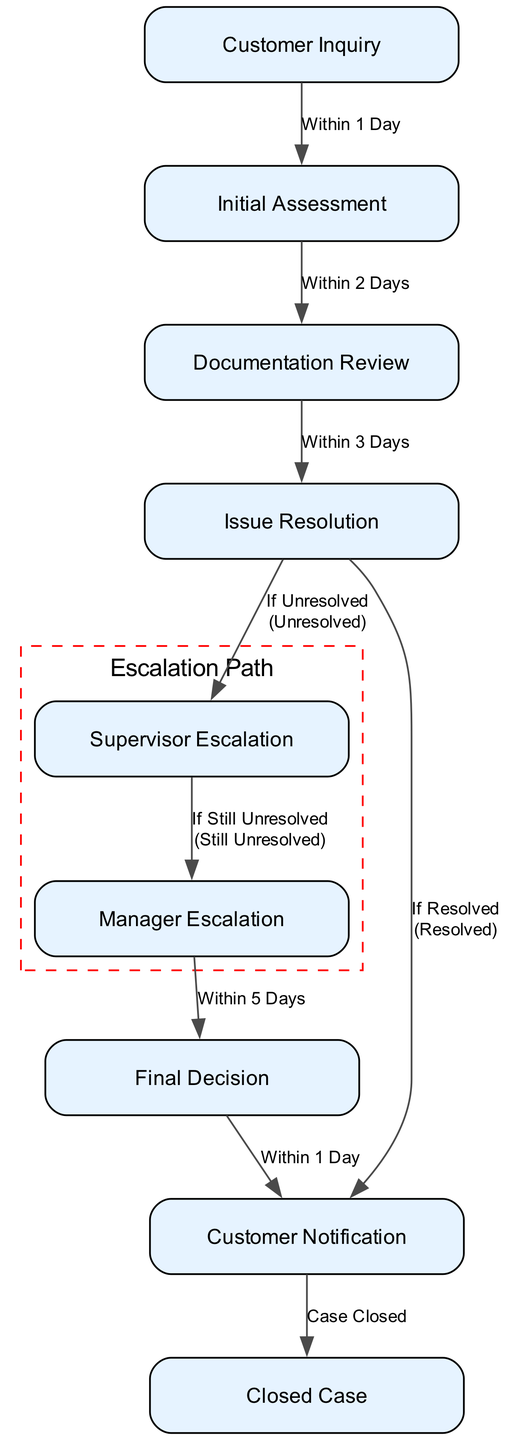What is the first node in the workflow diagram? The first node in the workflow diagram is "Customer Inquiry." This is determined by looking at the nodes listed in the diagram and identifying the one that initiates the process.
Answer: Customer Inquiry How many total nodes are present in the diagram? The diagram contains a total of 9 nodes, which can be counted from the list of nodes provided in the data.
Answer: 9 What is the condition for escalation to the supervisor? The condition for escalation to the supervisor is "If Unresolved." This is noted on the edge that leads from the "Issue Resolution" node to the "Supervisor Escalation" node, indicating when escalation is necessary.
Answer: If Unresolved What is the maximum number of days it takes to reach a final decision after a customer inquiry? To reach a final decision, it takes a maximum of 11 days: 1 day for initial assessment, 2 days for documentation review, plus 3 days for issue resolution, resulting in 6 total days. Then, the maximum is an additional 5 days for manager escalation, yielding 11 days overall.
Answer: 11 days Which node follows the final decision in the diagram? The node that follows the final decision is "Customer Notification." This is directly indicated by the edge connecting "Final Decision" to "Customer Notification."
Answer: Customer Notification What happens if the issue is resolved during the issue resolution phase? If the issue is resolved during the issue resolution phase, the process proceeds directly to "Customer Notification," as indicated by the edge labeled "If Resolved."
Answer: Customer Notification Identify the escalation path in the diagram. The escalation path includes moving from "Issue Resolution" to "Supervisor Escalation," and then from "Supervisor Escalation" to "Manager Escalation." This path is defined by the specific edges that indicate escalation scenarios.
Answer: Supervisor Escalation, Manager Escalation How long is the timeframe from manager escalation to final decision? The timeframe from manager escalation to final decision is 5 days, as specified on the edge that connects "Manager Escalation" to "Final Decision."
Answer: 5 days What node represents the closure of a case? The node that represents the closure of a case is "Closed Case." This is the final node in the workflow, indicating the completion of the process.
Answer: Closed Case 